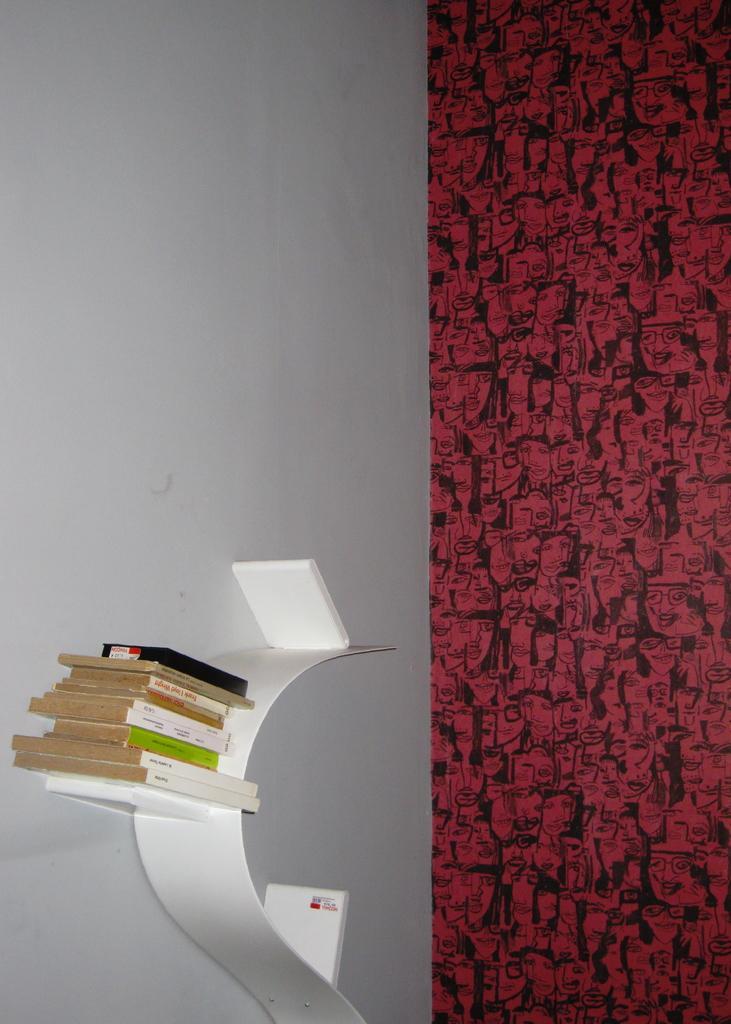Please provide a concise description of this image. In the picture I can see books on a white color object which is attached to the wall. On the right side of the image I can see red and black color design on the wall. 